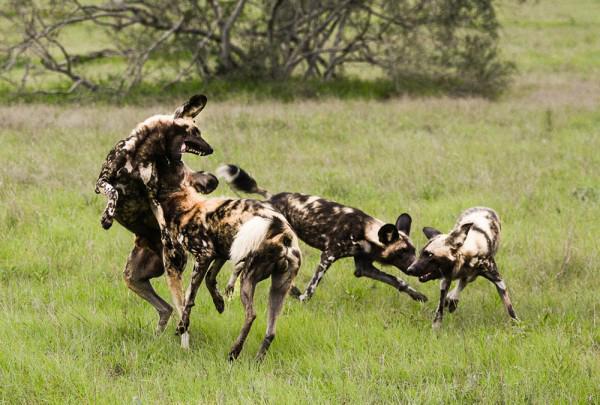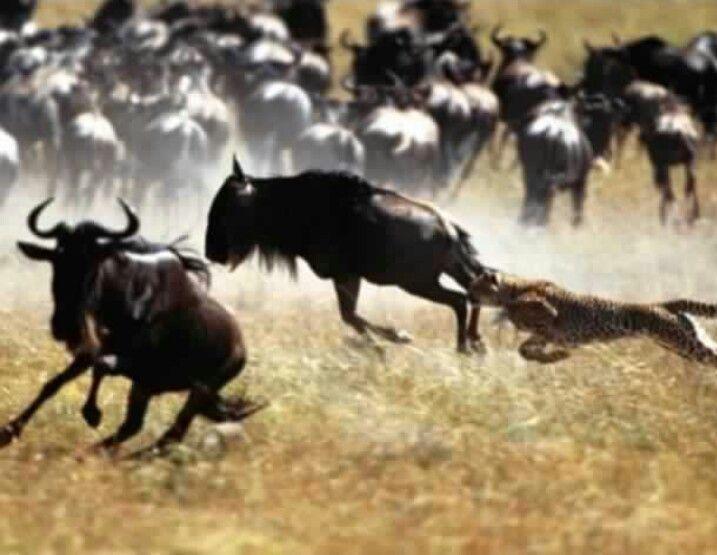The first image is the image on the left, the second image is the image on the right. Assess this claim about the two images: "An image shows a spotted wildcat standing on its hind legs, with its front paws grasping a horned animal.". Correct or not? Answer yes or no. No. The first image is the image on the left, the second image is the image on the right. Considering the images on both sides, is "a wildebeest is being held by two cheetahs" valid? Answer yes or no. No. 